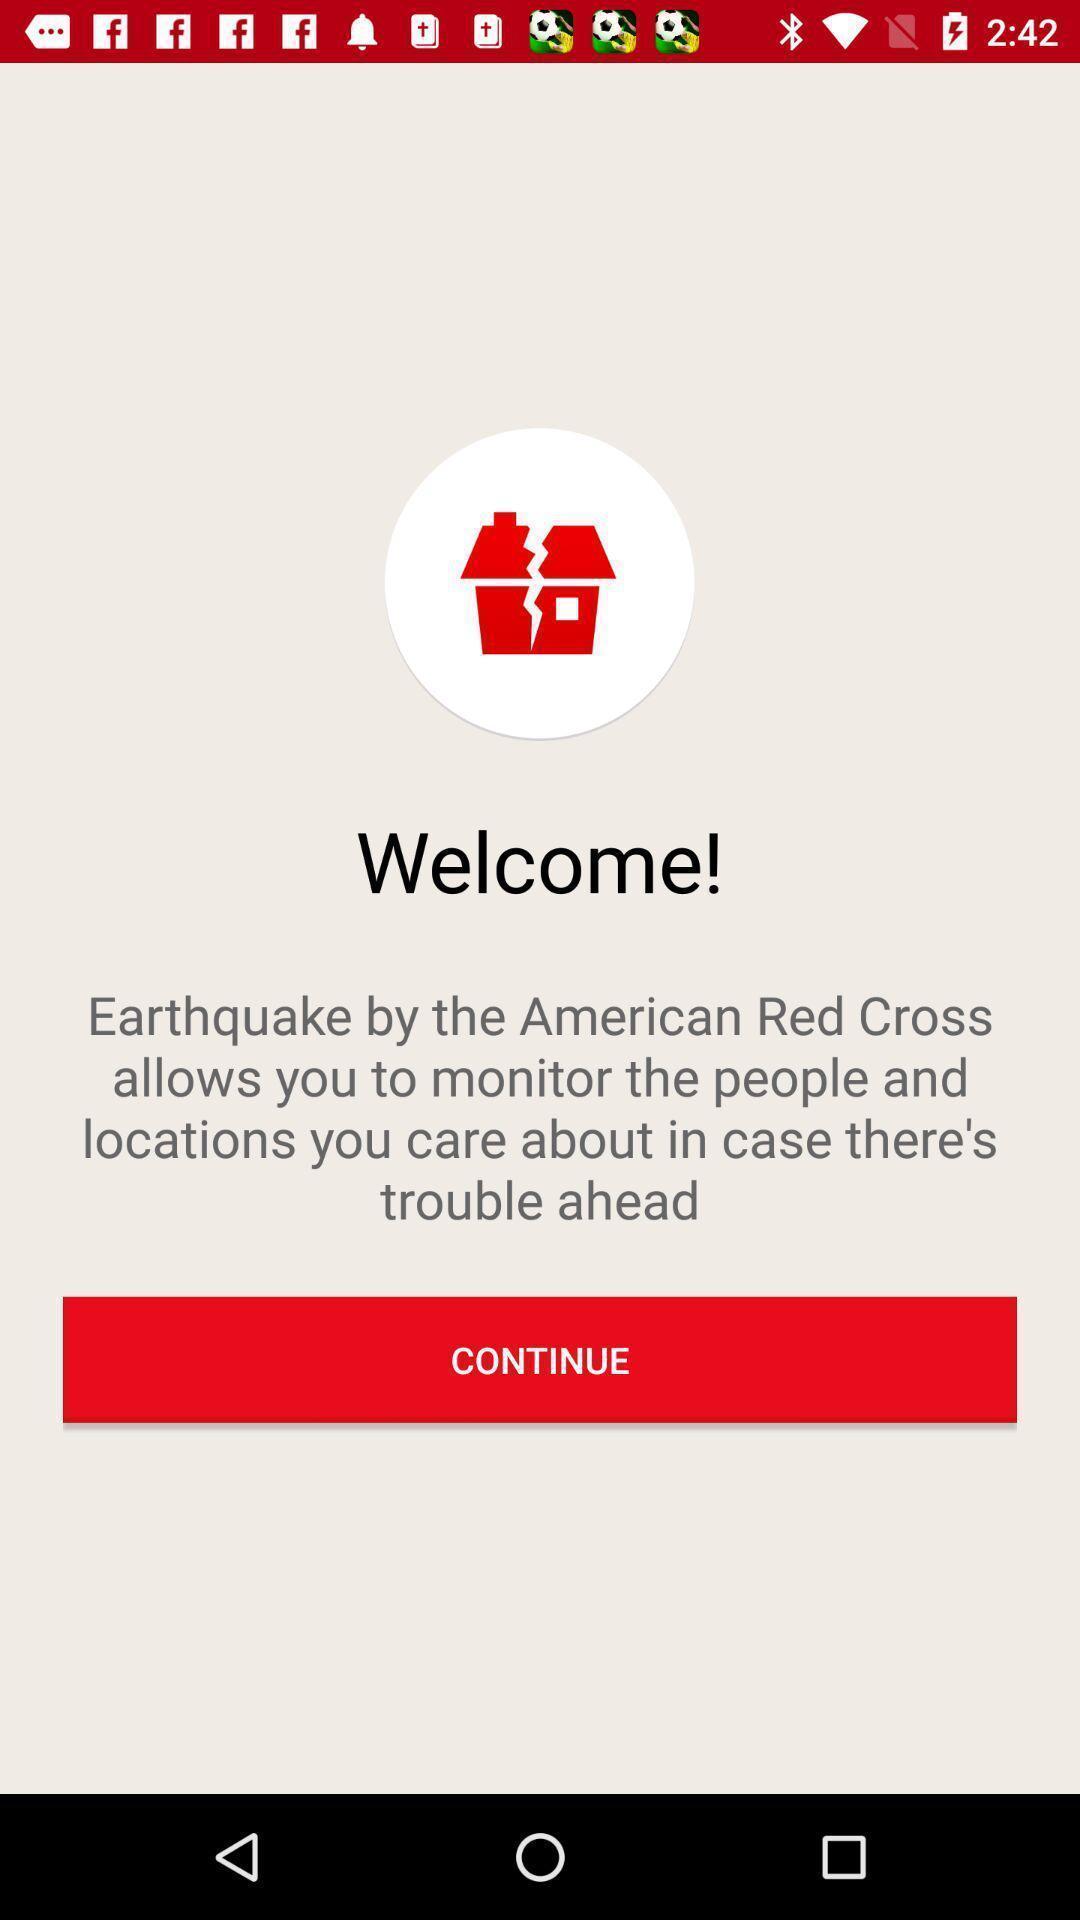Describe the visual elements of this screenshot. Welcome page of earthquake alert application. 